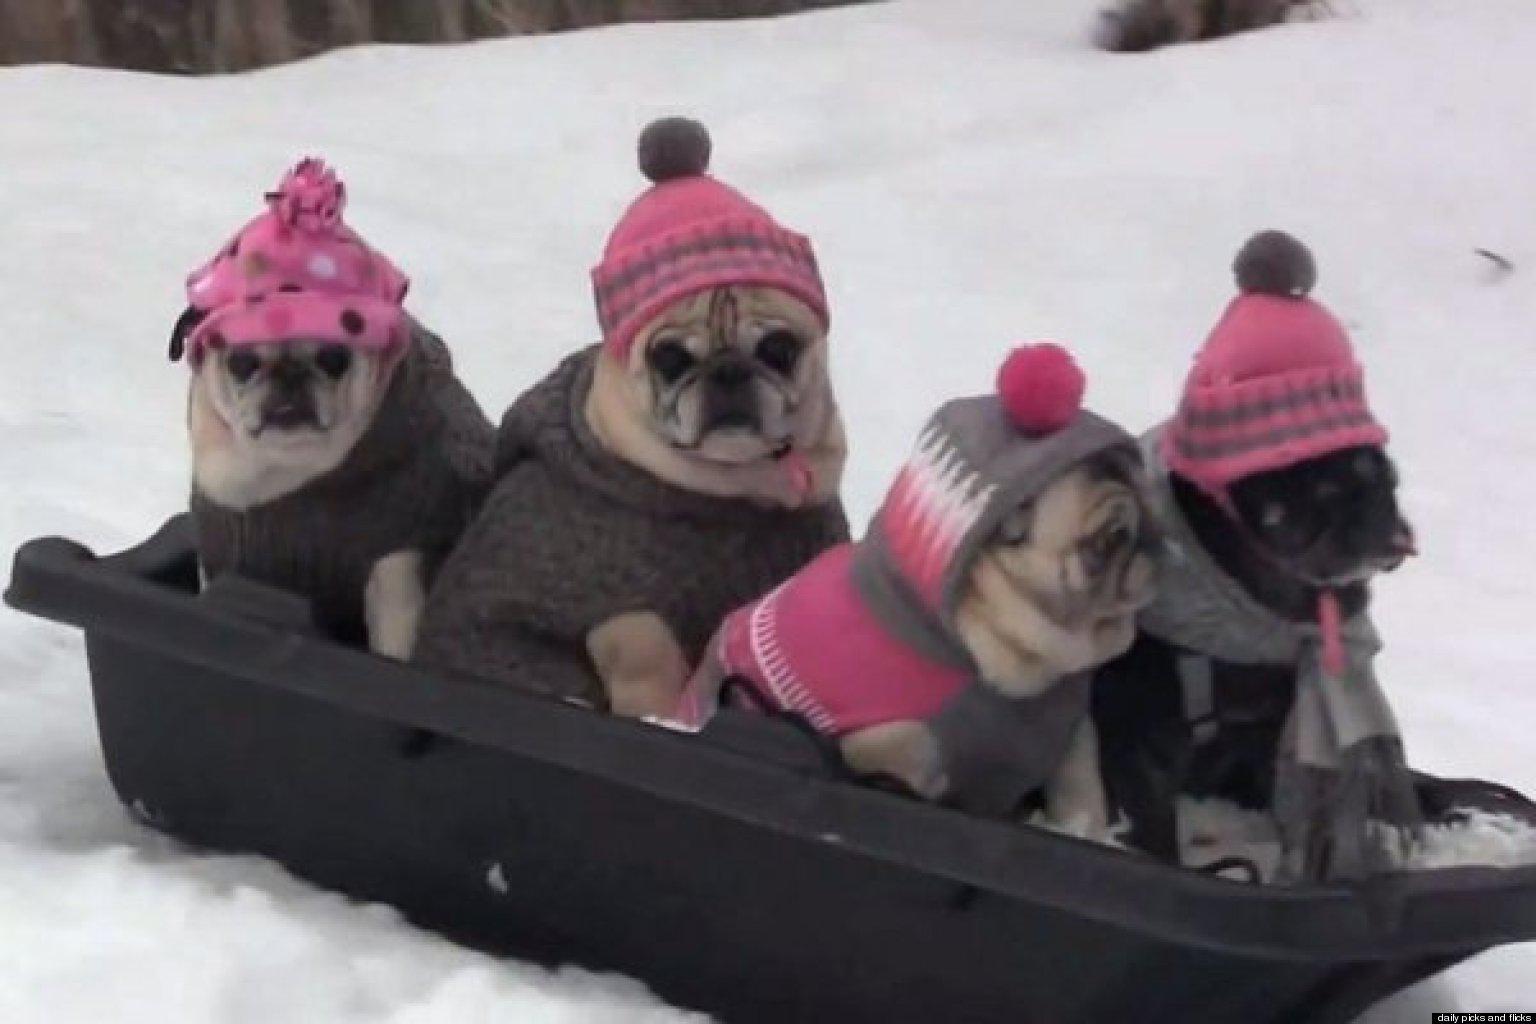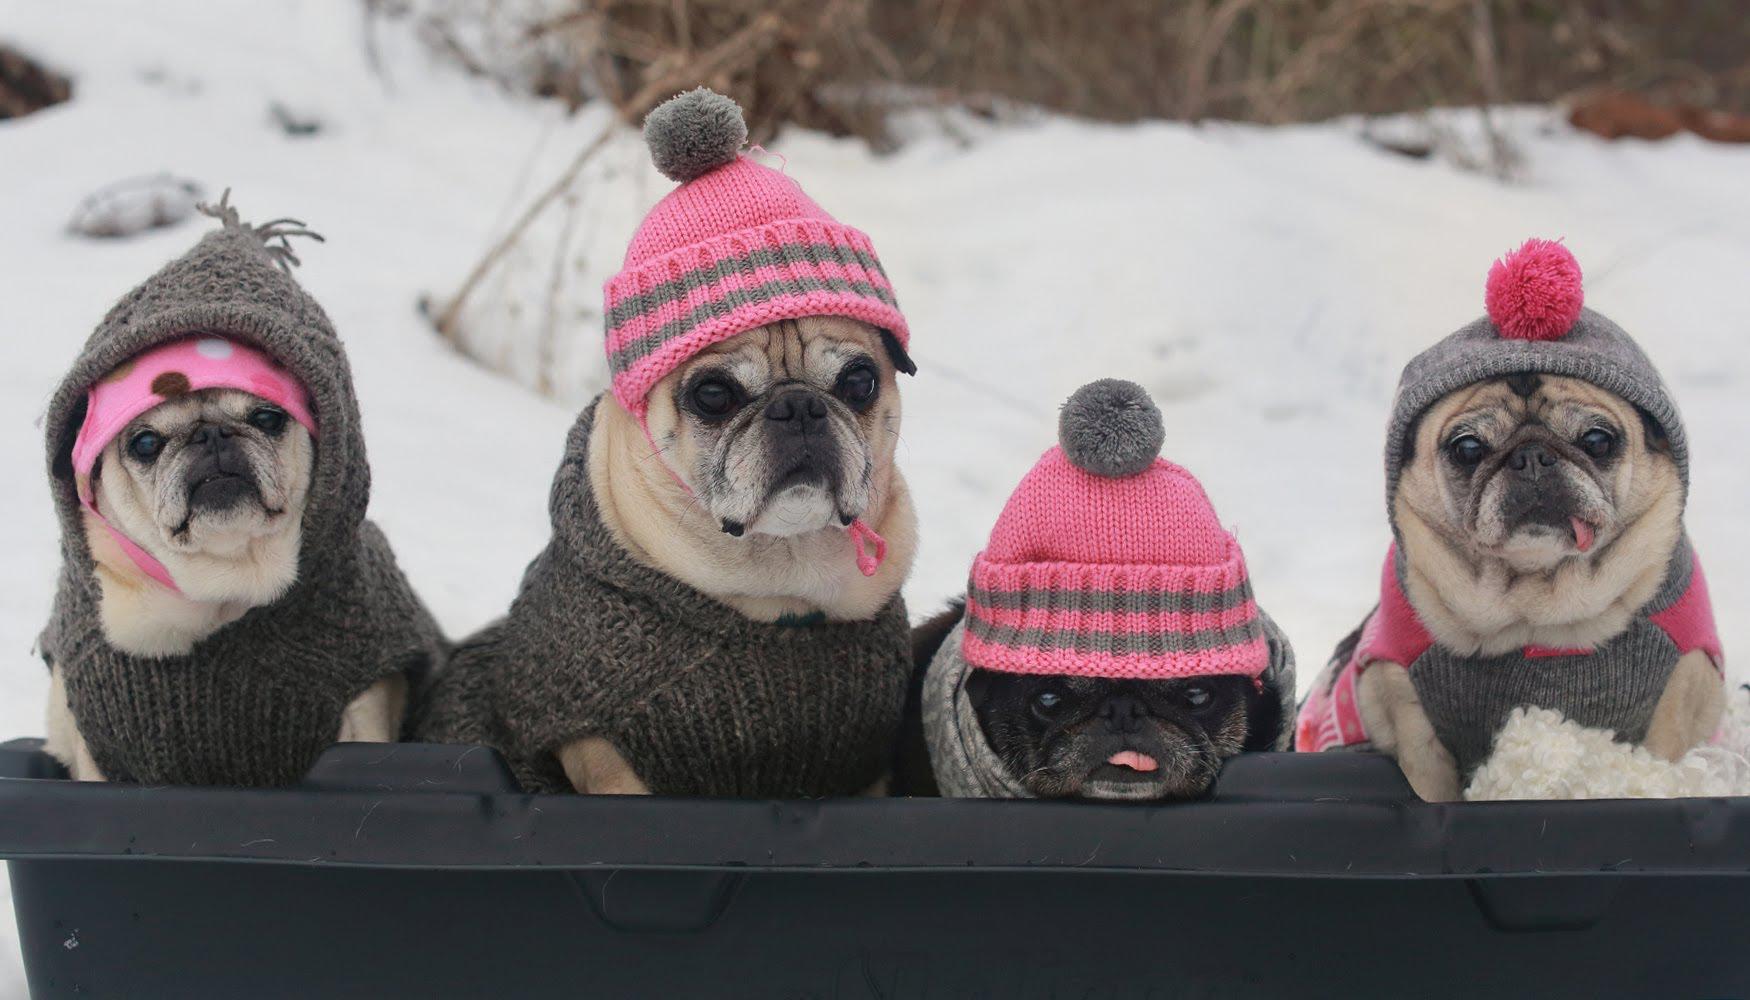The first image is the image on the left, the second image is the image on the right. For the images shown, is this caption "there is a human in the image on the left" true? Answer yes or no. No. The first image is the image on the left, the second image is the image on the right. For the images displayed, is the sentence "There are exactly 8 pugs sitting in a sled wearing hats." factually correct? Answer yes or no. Yes. 